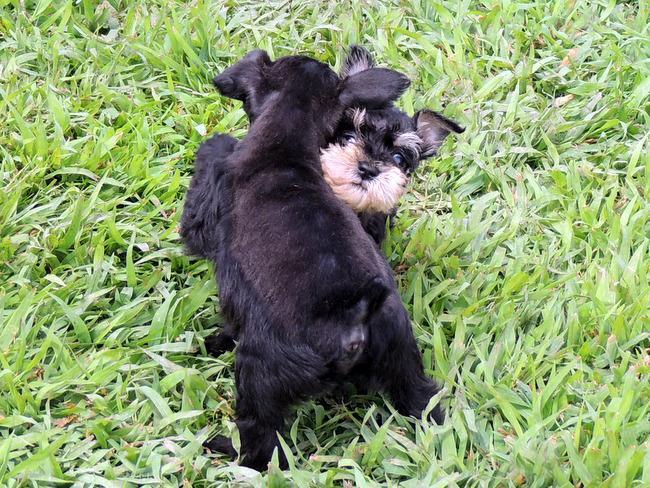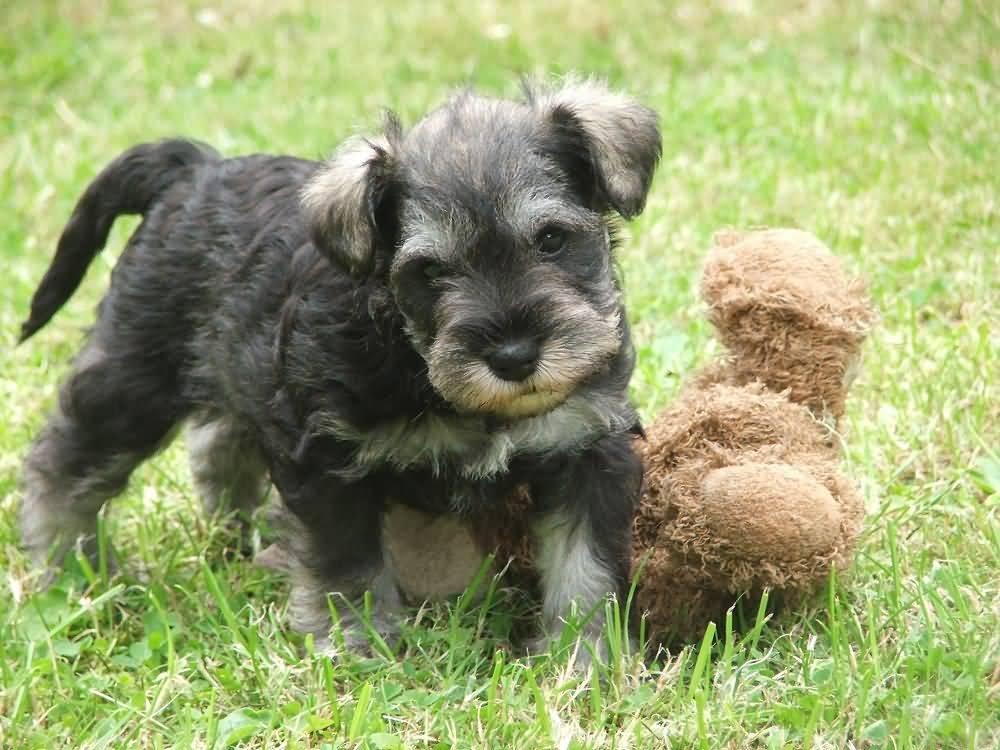The first image is the image on the left, the second image is the image on the right. Given the left and right images, does the statement "A single dog stands in the grass in the image on the right." hold true? Answer yes or no. Yes. The first image is the image on the left, the second image is the image on the right. Assess this claim about the two images: "An image shows one schnauzer puppy standing in the grass near a toy.". Correct or not? Answer yes or no. Yes. 